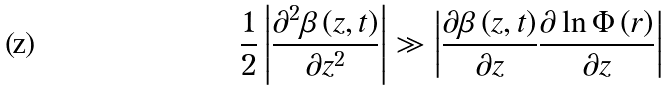<formula> <loc_0><loc_0><loc_500><loc_500>\frac { 1 } { 2 } \left | \frac { \partial ^ { 2 } \beta \left ( z , t \right ) } { \partial z ^ { 2 } } \right | \gg \left | \frac { \partial \beta \left ( z , t \right ) } { \partial z } \frac { \partial \ln \Phi \left ( { r } \right ) } { \partial z } \right |</formula> 